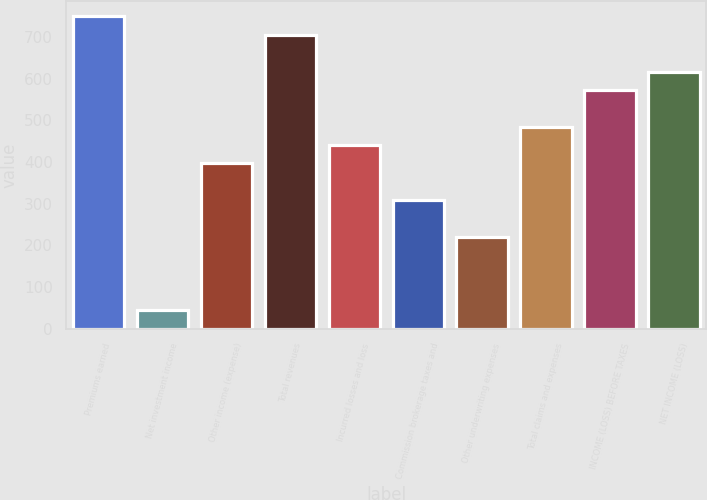Convert chart to OTSL. <chart><loc_0><loc_0><loc_500><loc_500><bar_chart><fcel>Premiums earned<fcel>Net investment income<fcel>Other income (expense)<fcel>Total revenues<fcel>Incurred losses and loss<fcel>Commission brokerage taxes and<fcel>Other underwriting expenses<fcel>Total claims and expenses<fcel>INCOME (LOSS) BEFORE TAXES<fcel>NET INCOME (LOSS)<nl><fcel>748.88<fcel>44.24<fcel>396.56<fcel>704.84<fcel>440.6<fcel>308.48<fcel>220.4<fcel>484.64<fcel>572.72<fcel>616.76<nl></chart> 